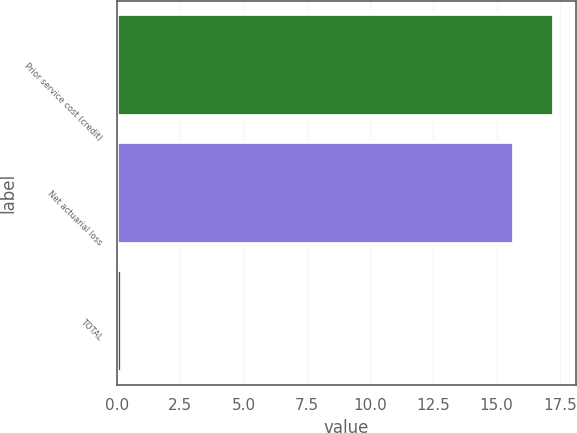<chart> <loc_0><loc_0><loc_500><loc_500><bar_chart><fcel>Prior service cost (credit)<fcel>Net actuarial loss<fcel>TOTAL<nl><fcel>17.27<fcel>15.7<fcel>0.2<nl></chart> 